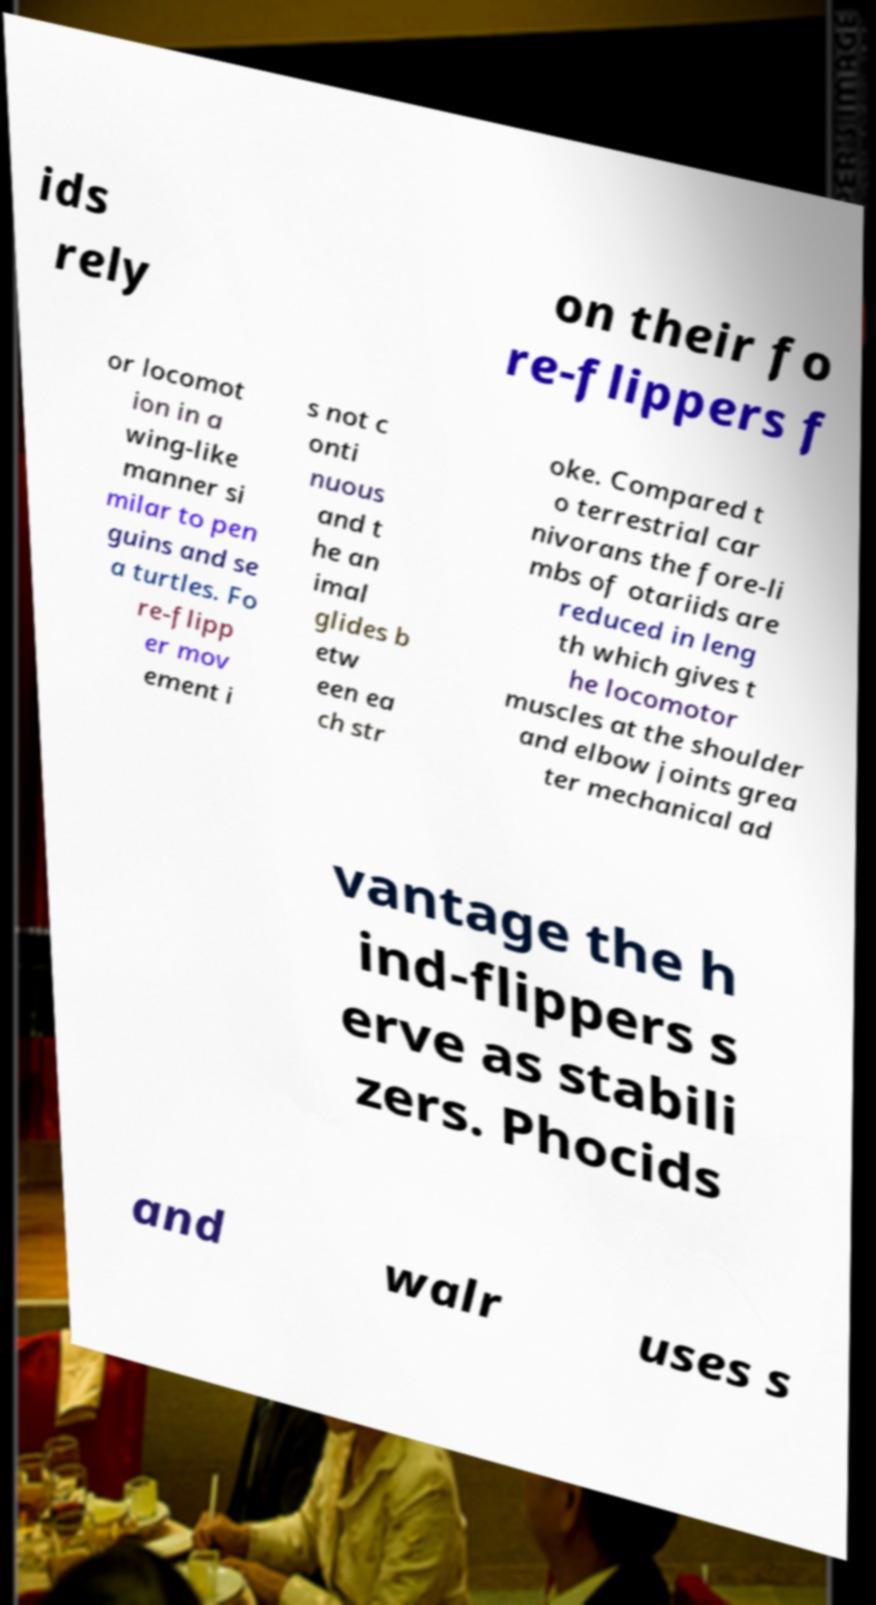Can you read and provide the text displayed in the image?This photo seems to have some interesting text. Can you extract and type it out for me? ids rely on their fo re-flippers f or locomot ion in a wing-like manner si milar to pen guins and se a turtles. Fo re-flipp er mov ement i s not c onti nuous and t he an imal glides b etw een ea ch str oke. Compared t o terrestrial car nivorans the fore-li mbs of otariids are reduced in leng th which gives t he locomotor muscles at the shoulder and elbow joints grea ter mechanical ad vantage the h ind-flippers s erve as stabili zers. Phocids and walr uses s 